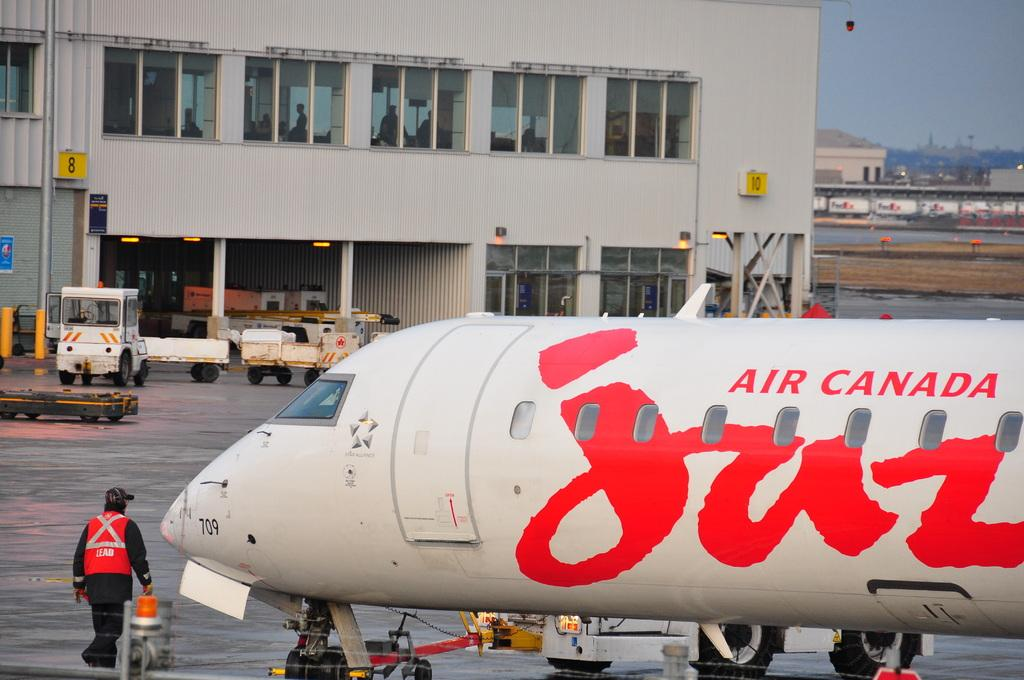Provide a one-sentence caption for the provided image. an airport with a man and a plane with AIR CANADA on it. 